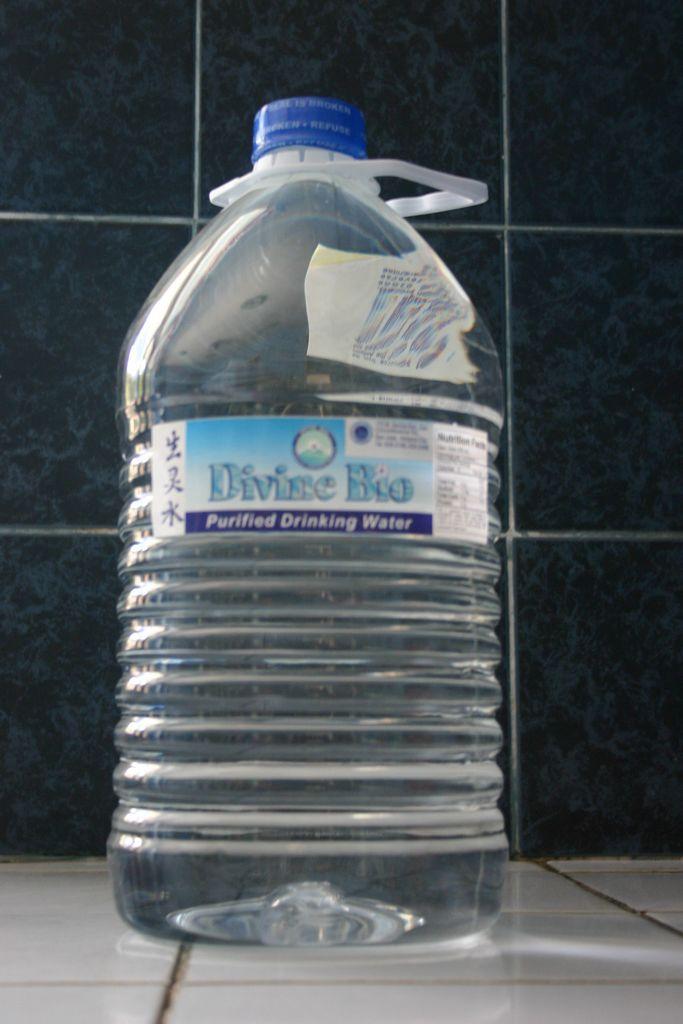What brand of water is in the bottle?
Offer a very short reply. Divine bio. 